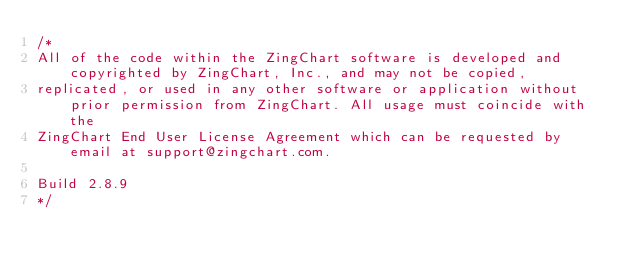Convert code to text. <code><loc_0><loc_0><loc_500><loc_500><_JavaScript_>/*
All of the code within the ZingChart software is developed and copyrighted by ZingChart, Inc., and may not be copied,
replicated, or used in any other software or application without prior permission from ZingChart. All usage must coincide with the
ZingChart End User License Agreement which can be requested by email at support@zingchart.com.

Build 2.8.9
*/</code> 